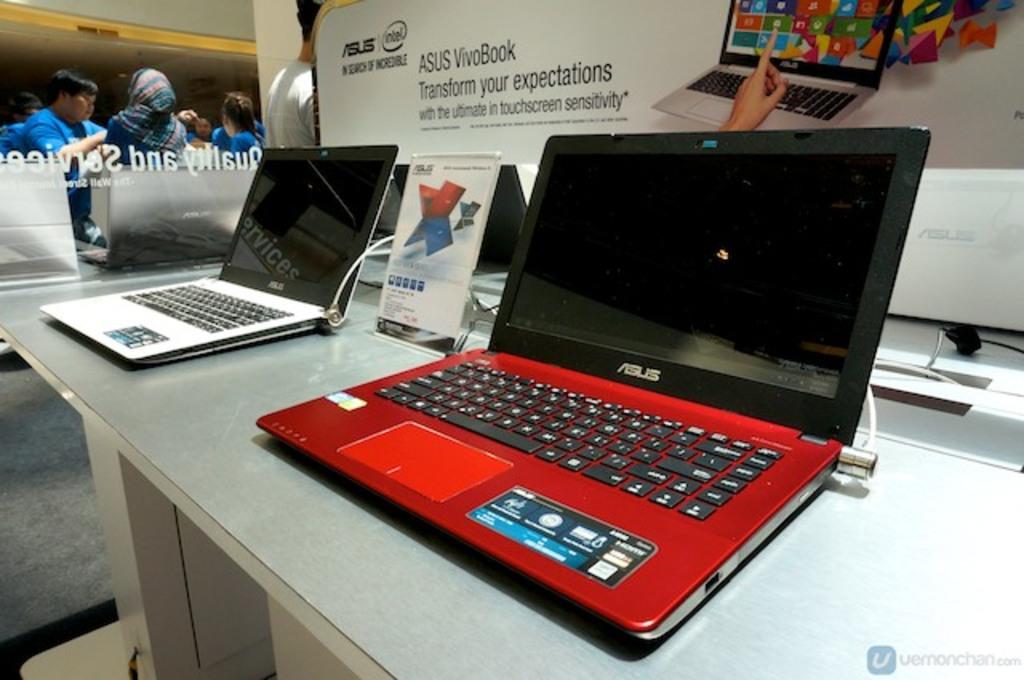What brand is that laptop?
Provide a succinct answer. Asus. What does the vivobook do to your expectations?
Keep it short and to the point. Transforms. 